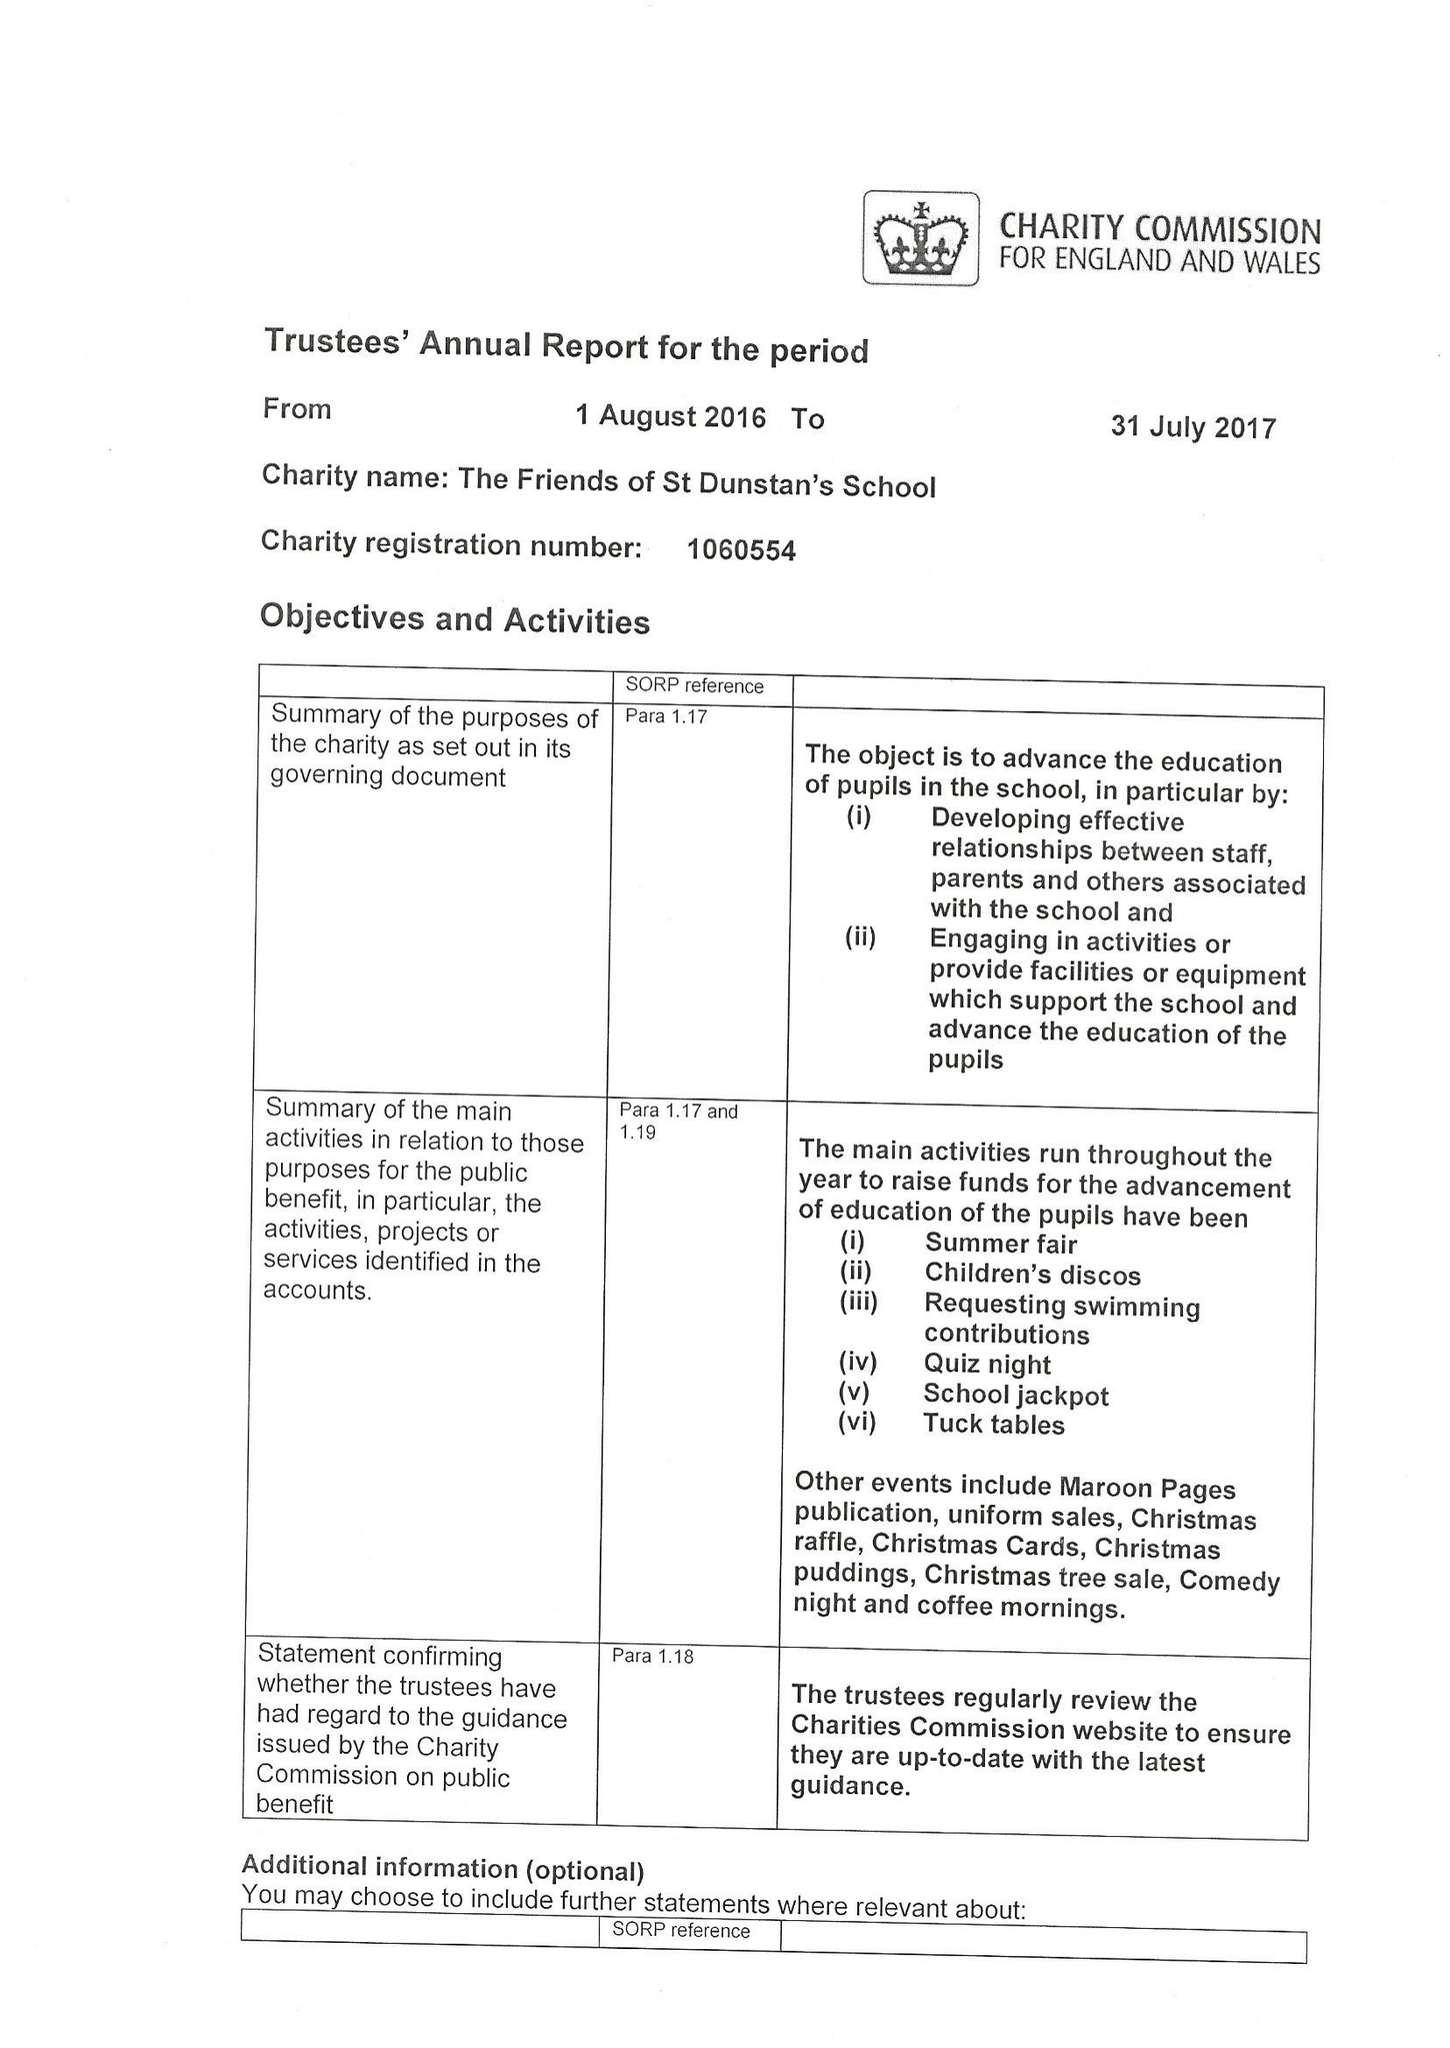What is the value for the report_date?
Answer the question using a single word or phrase. 2017-07-31 